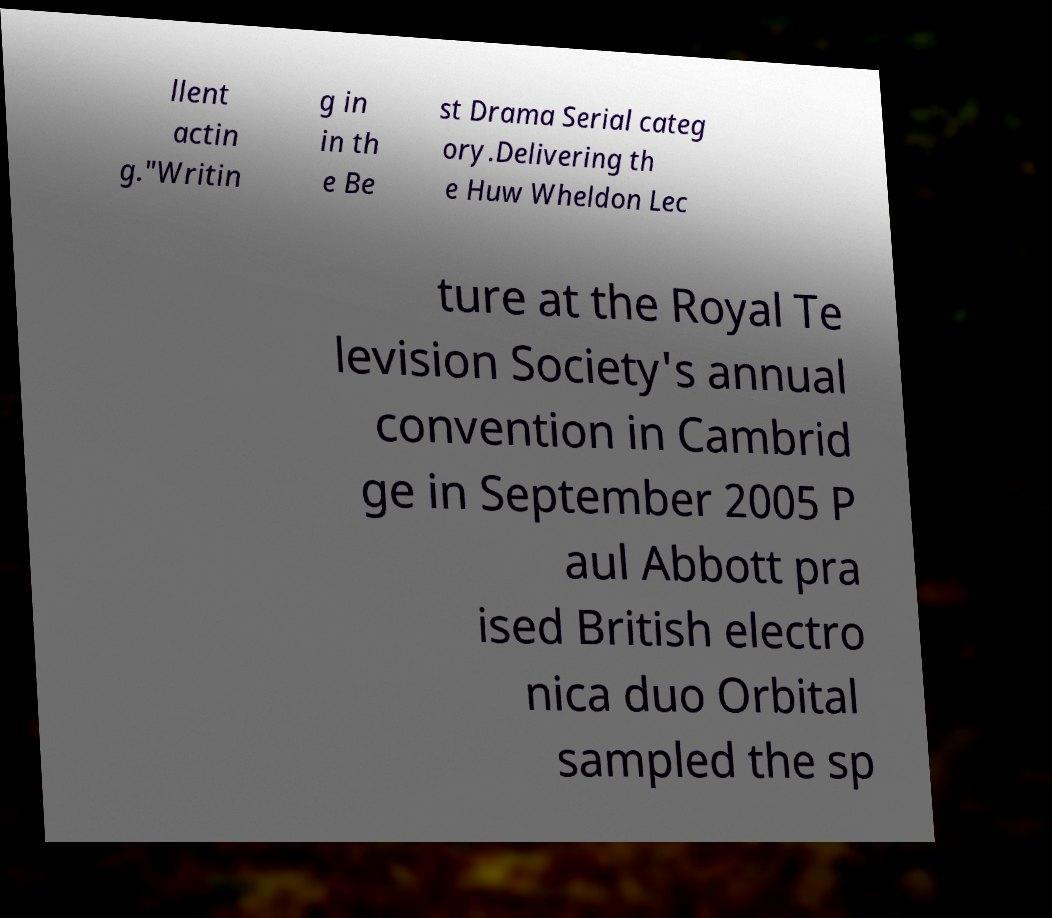I need the written content from this picture converted into text. Can you do that? llent actin g."Writin g in in th e Be st Drama Serial categ ory.Delivering th e Huw Wheldon Lec ture at the Royal Te levision Society's annual convention in Cambrid ge in September 2005 P aul Abbott pra ised British electro nica duo Orbital sampled the sp 